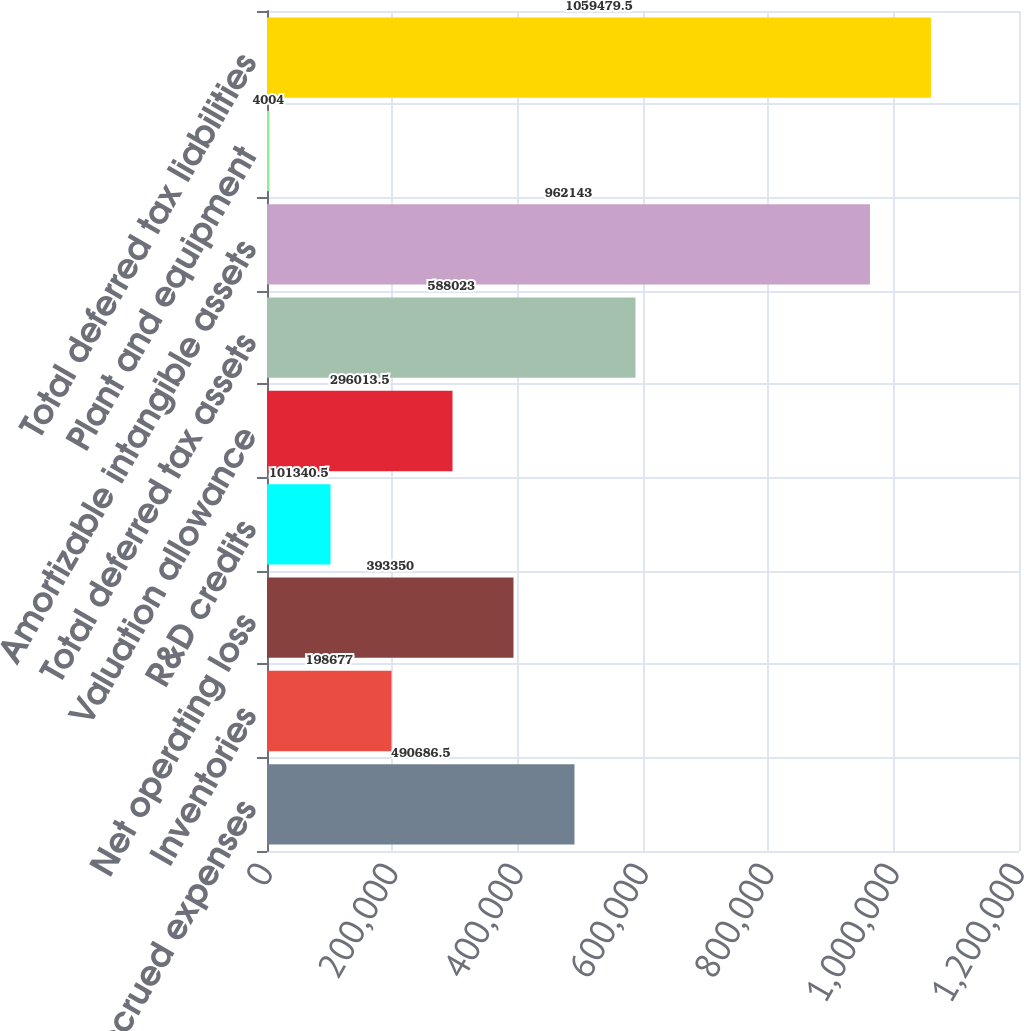Convert chart to OTSL. <chart><loc_0><loc_0><loc_500><loc_500><bar_chart><fcel>Reserves and accrued expenses<fcel>Inventories<fcel>Net operating loss<fcel>R&D credits<fcel>Valuation allowance<fcel>Total deferred tax assets<fcel>Amortizable intangible assets<fcel>Plant and equipment<fcel>Total deferred tax liabilities<nl><fcel>490686<fcel>198677<fcel>393350<fcel>101340<fcel>296014<fcel>588023<fcel>962143<fcel>4004<fcel>1.05948e+06<nl></chart> 